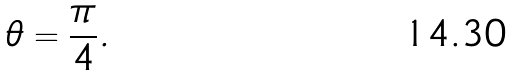<formula> <loc_0><loc_0><loc_500><loc_500>\theta = { \frac { \pi } { 4 } } .</formula> 